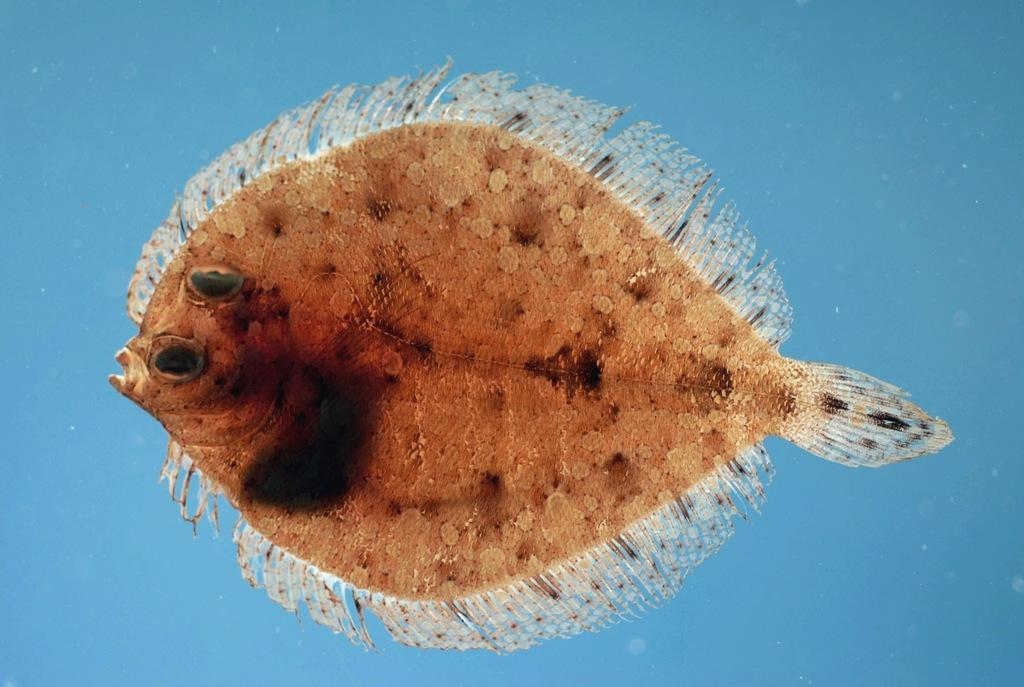What type of animal is in the image? There is a fish in the image. What color is the fish? The fish is brown in color. What can be seen in the background of the image? The background of the image is blue. How much salt is needed to preserve the fish in the image? There is no indication in the image that the fish is being preserved, nor is there any salt present. 